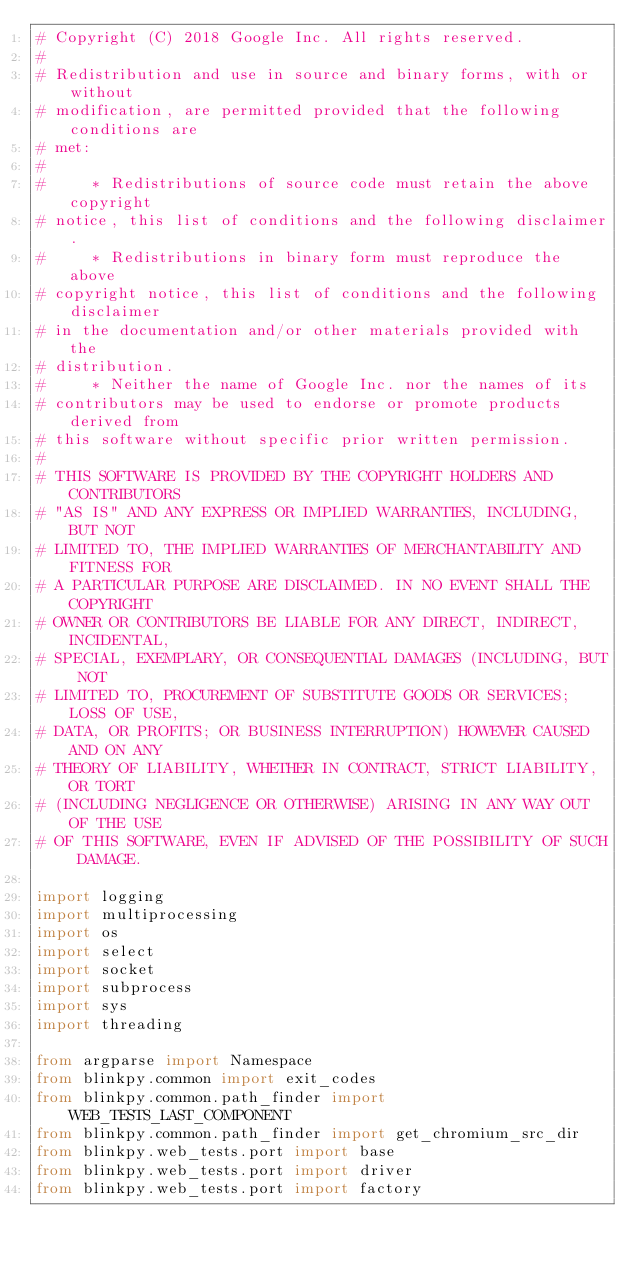Convert code to text. <code><loc_0><loc_0><loc_500><loc_500><_Python_># Copyright (C) 2018 Google Inc. All rights reserved.
#
# Redistribution and use in source and binary forms, with or without
# modification, are permitted provided that the following conditions are
# met:
#
#     * Redistributions of source code must retain the above copyright
# notice, this list of conditions and the following disclaimer.
#     * Redistributions in binary form must reproduce the above
# copyright notice, this list of conditions and the following disclaimer
# in the documentation and/or other materials provided with the
# distribution.
#     * Neither the name of Google Inc. nor the names of its
# contributors may be used to endorse or promote products derived from
# this software without specific prior written permission.
#
# THIS SOFTWARE IS PROVIDED BY THE COPYRIGHT HOLDERS AND CONTRIBUTORS
# "AS IS" AND ANY EXPRESS OR IMPLIED WARRANTIES, INCLUDING, BUT NOT
# LIMITED TO, THE IMPLIED WARRANTIES OF MERCHANTABILITY AND FITNESS FOR
# A PARTICULAR PURPOSE ARE DISCLAIMED. IN NO EVENT SHALL THE COPYRIGHT
# OWNER OR CONTRIBUTORS BE LIABLE FOR ANY DIRECT, INDIRECT, INCIDENTAL,
# SPECIAL, EXEMPLARY, OR CONSEQUENTIAL DAMAGES (INCLUDING, BUT NOT
# LIMITED TO, PROCUREMENT OF SUBSTITUTE GOODS OR SERVICES; LOSS OF USE,
# DATA, OR PROFITS; OR BUSINESS INTERRUPTION) HOWEVER CAUSED AND ON ANY
# THEORY OF LIABILITY, WHETHER IN CONTRACT, STRICT LIABILITY, OR TORT
# (INCLUDING NEGLIGENCE OR OTHERWISE) ARISING IN ANY WAY OUT OF THE USE
# OF THIS SOFTWARE, EVEN IF ADVISED OF THE POSSIBILITY OF SUCH DAMAGE.

import logging
import multiprocessing
import os
import select
import socket
import subprocess
import sys
import threading

from argparse import Namespace
from blinkpy.common import exit_codes
from blinkpy.common.path_finder import WEB_TESTS_LAST_COMPONENT
from blinkpy.common.path_finder import get_chromium_src_dir
from blinkpy.web_tests.port import base
from blinkpy.web_tests.port import driver
from blinkpy.web_tests.port import factory</code> 